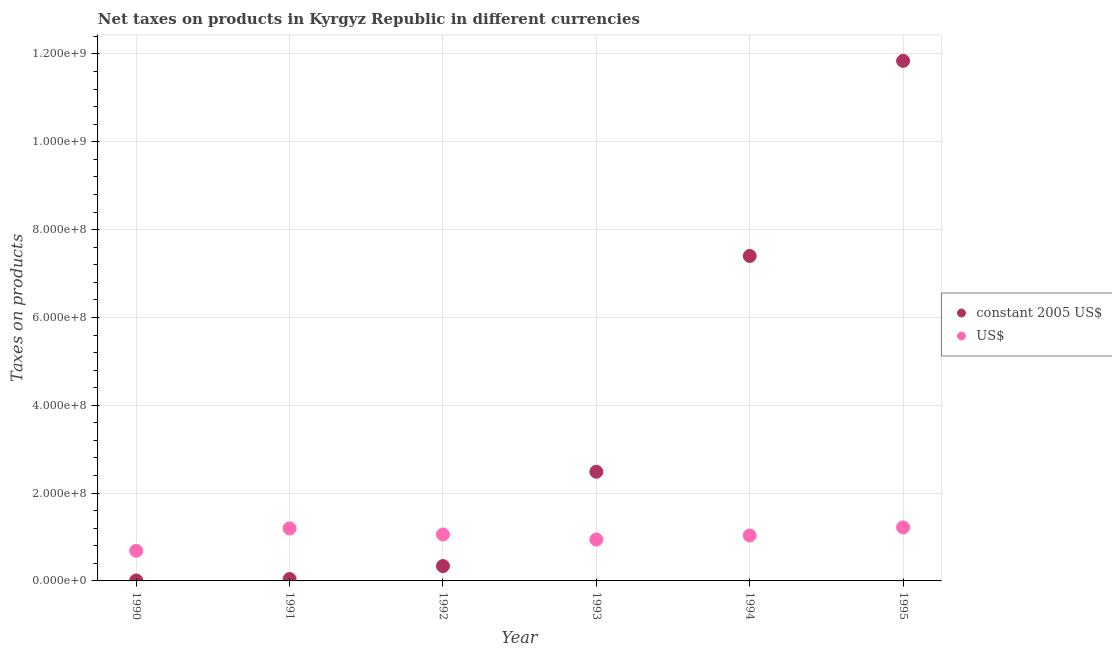What is the net taxes in constant 2005 us$ in 1992?
Your answer should be compact. 3.38e+07. Across all years, what is the maximum net taxes in constant 2005 us$?
Offer a terse response. 1.18e+09. Across all years, what is the minimum net taxes in us$?
Make the answer very short. 6.86e+07. What is the total net taxes in us$ in the graph?
Make the answer very short. 6.13e+08. What is the difference between the net taxes in us$ in 1990 and that in 1991?
Your response must be concise. -5.10e+07. What is the difference between the net taxes in us$ in 1994 and the net taxes in constant 2005 us$ in 1992?
Offer a very short reply. 6.96e+07. What is the average net taxes in us$ per year?
Offer a terse response. 1.02e+08. In the year 1993, what is the difference between the net taxes in us$ and net taxes in constant 2005 us$?
Keep it short and to the point. -1.54e+08. What is the ratio of the net taxes in us$ in 1992 to that in 1994?
Your answer should be compact. 1.02. Is the difference between the net taxes in us$ in 1992 and 1995 greater than the difference between the net taxes in constant 2005 us$ in 1992 and 1995?
Keep it short and to the point. Yes. What is the difference between the highest and the second highest net taxes in constant 2005 us$?
Provide a short and direct response. 4.44e+08. What is the difference between the highest and the lowest net taxes in us$?
Provide a short and direct response. 5.32e+07. Is the sum of the net taxes in us$ in 1994 and 1995 greater than the maximum net taxes in constant 2005 us$ across all years?
Give a very brief answer. No. How many years are there in the graph?
Provide a short and direct response. 6. Are the values on the major ticks of Y-axis written in scientific E-notation?
Offer a very short reply. Yes. Does the graph contain any zero values?
Your response must be concise. No. Does the graph contain grids?
Provide a succinct answer. Yes. Where does the legend appear in the graph?
Give a very brief answer. Center right. What is the title of the graph?
Ensure brevity in your answer.  Net taxes on products in Kyrgyz Republic in different currencies. What is the label or title of the X-axis?
Your answer should be very brief. Year. What is the label or title of the Y-axis?
Keep it short and to the point. Taxes on products. What is the Taxes on products in constant 2005 US$ in 1990?
Make the answer very short. 1.10e+06. What is the Taxes on products in US$ in 1990?
Your answer should be compact. 6.86e+07. What is the Taxes on products in constant 2005 US$ in 1991?
Provide a succinct answer. 4.30e+06. What is the Taxes on products in US$ in 1991?
Your response must be concise. 1.20e+08. What is the Taxes on products in constant 2005 US$ in 1992?
Give a very brief answer. 3.38e+07. What is the Taxes on products in US$ in 1992?
Keep it short and to the point. 1.06e+08. What is the Taxes on products in constant 2005 US$ in 1993?
Offer a very short reply. 2.49e+08. What is the Taxes on products in US$ in 1993?
Ensure brevity in your answer.  9.42e+07. What is the Taxes on products in constant 2005 US$ in 1994?
Your answer should be compact. 7.40e+08. What is the Taxes on products of US$ in 1994?
Offer a terse response. 1.03e+08. What is the Taxes on products in constant 2005 US$ in 1995?
Your response must be concise. 1.18e+09. What is the Taxes on products in US$ in 1995?
Ensure brevity in your answer.  1.22e+08. Across all years, what is the maximum Taxes on products of constant 2005 US$?
Your answer should be compact. 1.18e+09. Across all years, what is the maximum Taxes on products in US$?
Your answer should be compact. 1.22e+08. Across all years, what is the minimum Taxes on products in constant 2005 US$?
Give a very brief answer. 1.10e+06. Across all years, what is the minimum Taxes on products of US$?
Ensure brevity in your answer.  6.86e+07. What is the total Taxes on products of constant 2005 US$ in the graph?
Your answer should be compact. 2.21e+09. What is the total Taxes on products of US$ in the graph?
Offer a very short reply. 6.13e+08. What is the difference between the Taxes on products in constant 2005 US$ in 1990 and that in 1991?
Your answer should be compact. -3.21e+06. What is the difference between the Taxes on products in US$ in 1990 and that in 1991?
Provide a short and direct response. -5.10e+07. What is the difference between the Taxes on products of constant 2005 US$ in 1990 and that in 1992?
Give a very brief answer. -3.28e+07. What is the difference between the Taxes on products in US$ in 1990 and that in 1992?
Provide a succinct answer. -3.72e+07. What is the difference between the Taxes on products in constant 2005 US$ in 1990 and that in 1993?
Provide a succinct answer. -2.48e+08. What is the difference between the Taxes on products in US$ in 1990 and that in 1993?
Your answer should be compact. -2.55e+07. What is the difference between the Taxes on products of constant 2005 US$ in 1990 and that in 1994?
Your answer should be very brief. -7.39e+08. What is the difference between the Taxes on products of US$ in 1990 and that in 1994?
Offer a very short reply. -3.49e+07. What is the difference between the Taxes on products in constant 2005 US$ in 1990 and that in 1995?
Your answer should be very brief. -1.18e+09. What is the difference between the Taxes on products in US$ in 1990 and that in 1995?
Offer a terse response. -5.32e+07. What is the difference between the Taxes on products in constant 2005 US$ in 1991 and that in 1992?
Make the answer very short. -2.95e+07. What is the difference between the Taxes on products of US$ in 1991 and that in 1992?
Keep it short and to the point. 1.38e+07. What is the difference between the Taxes on products in constant 2005 US$ in 1991 and that in 1993?
Offer a terse response. -2.44e+08. What is the difference between the Taxes on products in US$ in 1991 and that in 1993?
Make the answer very short. 2.54e+07. What is the difference between the Taxes on products in constant 2005 US$ in 1991 and that in 1994?
Your response must be concise. -7.36e+08. What is the difference between the Taxes on products in US$ in 1991 and that in 1994?
Make the answer very short. 1.61e+07. What is the difference between the Taxes on products of constant 2005 US$ in 1991 and that in 1995?
Provide a short and direct response. -1.18e+09. What is the difference between the Taxes on products in US$ in 1991 and that in 1995?
Your response must be concise. -2.26e+06. What is the difference between the Taxes on products in constant 2005 US$ in 1992 and that in 1993?
Provide a short and direct response. -2.15e+08. What is the difference between the Taxes on products of US$ in 1992 and that in 1993?
Ensure brevity in your answer.  1.16e+07. What is the difference between the Taxes on products in constant 2005 US$ in 1992 and that in 1994?
Your answer should be very brief. -7.06e+08. What is the difference between the Taxes on products of US$ in 1992 and that in 1994?
Offer a terse response. 2.28e+06. What is the difference between the Taxes on products of constant 2005 US$ in 1992 and that in 1995?
Keep it short and to the point. -1.15e+09. What is the difference between the Taxes on products of US$ in 1992 and that in 1995?
Give a very brief answer. -1.61e+07. What is the difference between the Taxes on products of constant 2005 US$ in 1993 and that in 1994?
Give a very brief answer. -4.91e+08. What is the difference between the Taxes on products of US$ in 1993 and that in 1994?
Your answer should be very brief. -9.33e+06. What is the difference between the Taxes on products of constant 2005 US$ in 1993 and that in 1995?
Your response must be concise. -9.36e+08. What is the difference between the Taxes on products in US$ in 1993 and that in 1995?
Give a very brief answer. -2.77e+07. What is the difference between the Taxes on products in constant 2005 US$ in 1994 and that in 1995?
Your answer should be compact. -4.44e+08. What is the difference between the Taxes on products of US$ in 1994 and that in 1995?
Make the answer very short. -1.83e+07. What is the difference between the Taxes on products of constant 2005 US$ in 1990 and the Taxes on products of US$ in 1991?
Your response must be concise. -1.18e+08. What is the difference between the Taxes on products of constant 2005 US$ in 1990 and the Taxes on products of US$ in 1992?
Offer a terse response. -1.05e+08. What is the difference between the Taxes on products in constant 2005 US$ in 1990 and the Taxes on products in US$ in 1993?
Make the answer very short. -9.31e+07. What is the difference between the Taxes on products of constant 2005 US$ in 1990 and the Taxes on products of US$ in 1994?
Provide a succinct answer. -1.02e+08. What is the difference between the Taxes on products of constant 2005 US$ in 1990 and the Taxes on products of US$ in 1995?
Offer a terse response. -1.21e+08. What is the difference between the Taxes on products in constant 2005 US$ in 1991 and the Taxes on products in US$ in 1992?
Your answer should be compact. -1.01e+08. What is the difference between the Taxes on products in constant 2005 US$ in 1991 and the Taxes on products in US$ in 1993?
Your response must be concise. -8.99e+07. What is the difference between the Taxes on products in constant 2005 US$ in 1991 and the Taxes on products in US$ in 1994?
Ensure brevity in your answer.  -9.92e+07. What is the difference between the Taxes on products of constant 2005 US$ in 1991 and the Taxes on products of US$ in 1995?
Make the answer very short. -1.18e+08. What is the difference between the Taxes on products in constant 2005 US$ in 1992 and the Taxes on products in US$ in 1993?
Your response must be concise. -6.03e+07. What is the difference between the Taxes on products of constant 2005 US$ in 1992 and the Taxes on products of US$ in 1994?
Provide a short and direct response. -6.96e+07. What is the difference between the Taxes on products of constant 2005 US$ in 1992 and the Taxes on products of US$ in 1995?
Keep it short and to the point. -8.80e+07. What is the difference between the Taxes on products in constant 2005 US$ in 1993 and the Taxes on products in US$ in 1994?
Your answer should be compact. 1.45e+08. What is the difference between the Taxes on products of constant 2005 US$ in 1993 and the Taxes on products of US$ in 1995?
Offer a terse response. 1.27e+08. What is the difference between the Taxes on products of constant 2005 US$ in 1994 and the Taxes on products of US$ in 1995?
Keep it short and to the point. 6.18e+08. What is the average Taxes on products of constant 2005 US$ per year?
Make the answer very short. 3.69e+08. What is the average Taxes on products in US$ per year?
Provide a succinct answer. 1.02e+08. In the year 1990, what is the difference between the Taxes on products of constant 2005 US$ and Taxes on products of US$?
Offer a very short reply. -6.75e+07. In the year 1991, what is the difference between the Taxes on products of constant 2005 US$ and Taxes on products of US$?
Offer a terse response. -1.15e+08. In the year 1992, what is the difference between the Taxes on products of constant 2005 US$ and Taxes on products of US$?
Provide a short and direct response. -7.19e+07. In the year 1993, what is the difference between the Taxes on products of constant 2005 US$ and Taxes on products of US$?
Provide a short and direct response. 1.54e+08. In the year 1994, what is the difference between the Taxes on products in constant 2005 US$ and Taxes on products in US$?
Your response must be concise. 6.37e+08. In the year 1995, what is the difference between the Taxes on products in constant 2005 US$ and Taxes on products in US$?
Keep it short and to the point. 1.06e+09. What is the ratio of the Taxes on products in constant 2005 US$ in 1990 to that in 1991?
Ensure brevity in your answer.  0.26. What is the ratio of the Taxes on products of US$ in 1990 to that in 1991?
Offer a terse response. 0.57. What is the ratio of the Taxes on products in constant 2005 US$ in 1990 to that in 1992?
Ensure brevity in your answer.  0.03. What is the ratio of the Taxes on products of US$ in 1990 to that in 1992?
Your answer should be very brief. 0.65. What is the ratio of the Taxes on products in constant 2005 US$ in 1990 to that in 1993?
Give a very brief answer. 0. What is the ratio of the Taxes on products in US$ in 1990 to that in 1993?
Provide a succinct answer. 0.73. What is the ratio of the Taxes on products in constant 2005 US$ in 1990 to that in 1994?
Make the answer very short. 0. What is the ratio of the Taxes on products of US$ in 1990 to that in 1994?
Ensure brevity in your answer.  0.66. What is the ratio of the Taxes on products of constant 2005 US$ in 1990 to that in 1995?
Your response must be concise. 0. What is the ratio of the Taxes on products of US$ in 1990 to that in 1995?
Give a very brief answer. 0.56. What is the ratio of the Taxes on products of constant 2005 US$ in 1991 to that in 1992?
Offer a very short reply. 0.13. What is the ratio of the Taxes on products of US$ in 1991 to that in 1992?
Your answer should be compact. 1.13. What is the ratio of the Taxes on products in constant 2005 US$ in 1991 to that in 1993?
Provide a succinct answer. 0.02. What is the ratio of the Taxes on products in US$ in 1991 to that in 1993?
Your response must be concise. 1.27. What is the ratio of the Taxes on products in constant 2005 US$ in 1991 to that in 1994?
Your response must be concise. 0.01. What is the ratio of the Taxes on products of US$ in 1991 to that in 1994?
Provide a short and direct response. 1.16. What is the ratio of the Taxes on products in constant 2005 US$ in 1991 to that in 1995?
Keep it short and to the point. 0. What is the ratio of the Taxes on products in US$ in 1991 to that in 1995?
Give a very brief answer. 0.98. What is the ratio of the Taxes on products in constant 2005 US$ in 1992 to that in 1993?
Keep it short and to the point. 0.14. What is the ratio of the Taxes on products of US$ in 1992 to that in 1993?
Your response must be concise. 1.12. What is the ratio of the Taxes on products of constant 2005 US$ in 1992 to that in 1994?
Ensure brevity in your answer.  0.05. What is the ratio of the Taxes on products in constant 2005 US$ in 1992 to that in 1995?
Give a very brief answer. 0.03. What is the ratio of the Taxes on products in US$ in 1992 to that in 1995?
Your response must be concise. 0.87. What is the ratio of the Taxes on products of constant 2005 US$ in 1993 to that in 1994?
Your response must be concise. 0.34. What is the ratio of the Taxes on products in US$ in 1993 to that in 1994?
Ensure brevity in your answer.  0.91. What is the ratio of the Taxes on products in constant 2005 US$ in 1993 to that in 1995?
Your answer should be very brief. 0.21. What is the ratio of the Taxes on products in US$ in 1993 to that in 1995?
Provide a short and direct response. 0.77. What is the ratio of the Taxes on products in constant 2005 US$ in 1994 to that in 1995?
Ensure brevity in your answer.  0.62. What is the ratio of the Taxes on products of US$ in 1994 to that in 1995?
Your response must be concise. 0.85. What is the difference between the highest and the second highest Taxes on products of constant 2005 US$?
Offer a very short reply. 4.44e+08. What is the difference between the highest and the second highest Taxes on products of US$?
Ensure brevity in your answer.  2.26e+06. What is the difference between the highest and the lowest Taxes on products in constant 2005 US$?
Your answer should be compact. 1.18e+09. What is the difference between the highest and the lowest Taxes on products in US$?
Your answer should be very brief. 5.32e+07. 